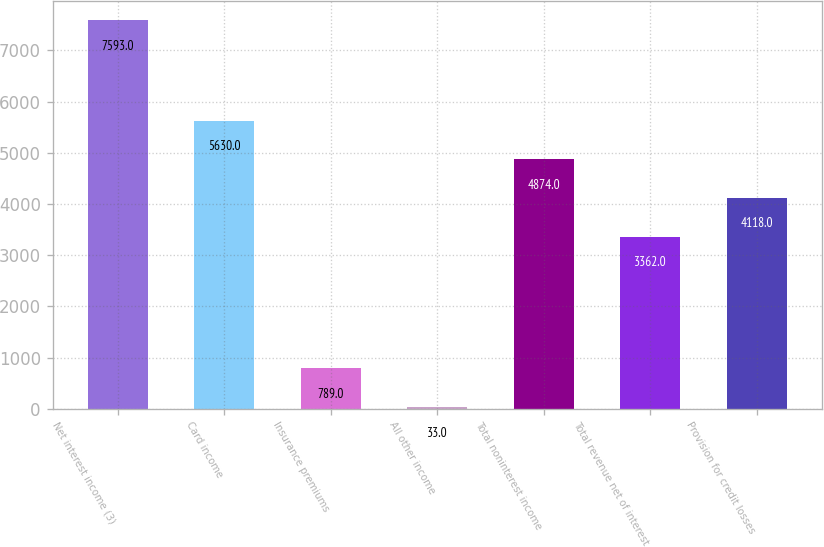Convert chart to OTSL. <chart><loc_0><loc_0><loc_500><loc_500><bar_chart><fcel>Net interest income (3)<fcel>Card income<fcel>Insurance premiums<fcel>All other income<fcel>Total noninterest income<fcel>Total revenue net of interest<fcel>Provision for credit losses<nl><fcel>7593<fcel>5630<fcel>789<fcel>33<fcel>4874<fcel>3362<fcel>4118<nl></chart> 